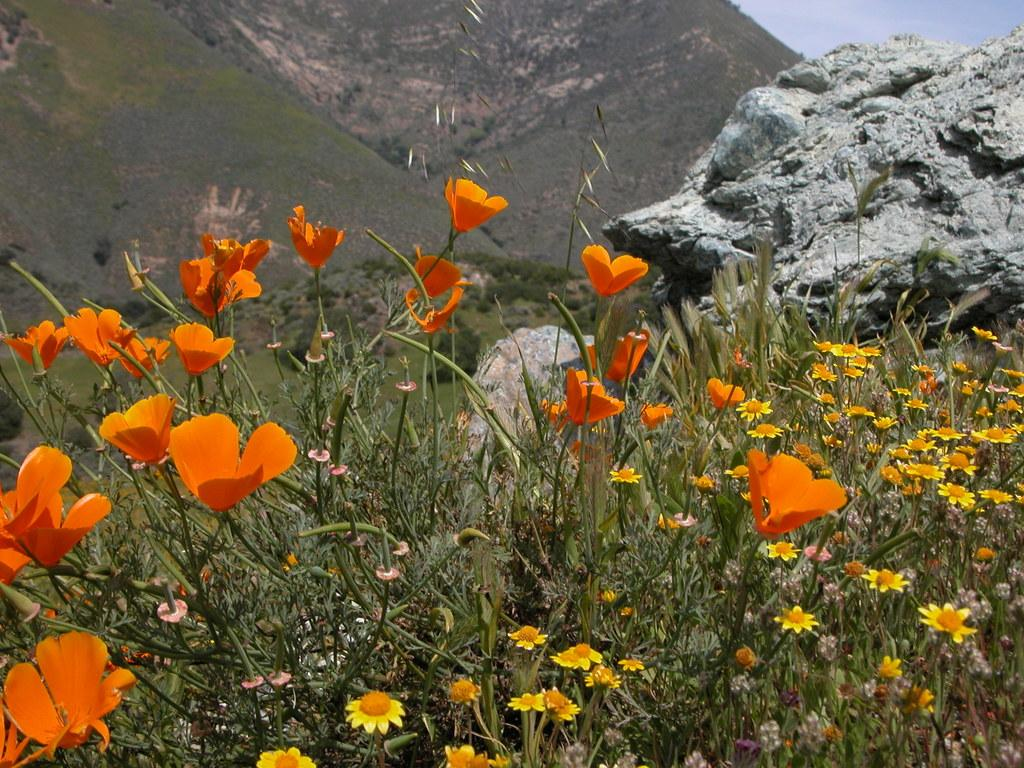What type of flora can be seen in the image? There are colorful flowers in the image. What else can be seen in the image besides the flowers? There are plants in the image. What can be seen in the background of the image? Hills and the sky are visible in the background of the image. What type of wax is being used to create the competition in the image? There is no wax or competition present in the image; it features colorful flowers and plants with a background of hills and the sky. 